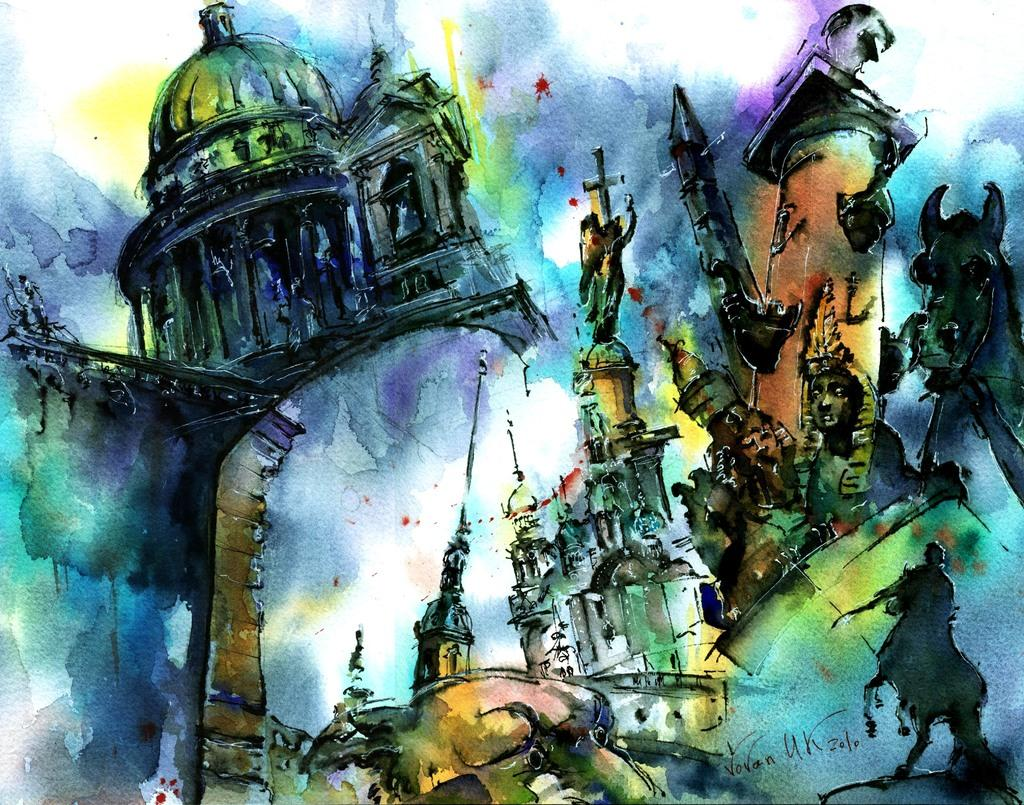What type of structure is depicted in the painting? There is a building in the painting. What religious symbol can be seen in the painting? There is a cross in the painting. What type of living creatures are present in the painting? There are animals in the painting. What other objects or elements are present in the painting? There are other objects in the painting. Can you see any pets in the painting? There is no mention of pets in the provided facts, so we cannot determine if there are any in the painting. Is there an airport depicted in the painting? There is no mention of an airport in the provided facts, so we cannot determine if there is one in the painting. 